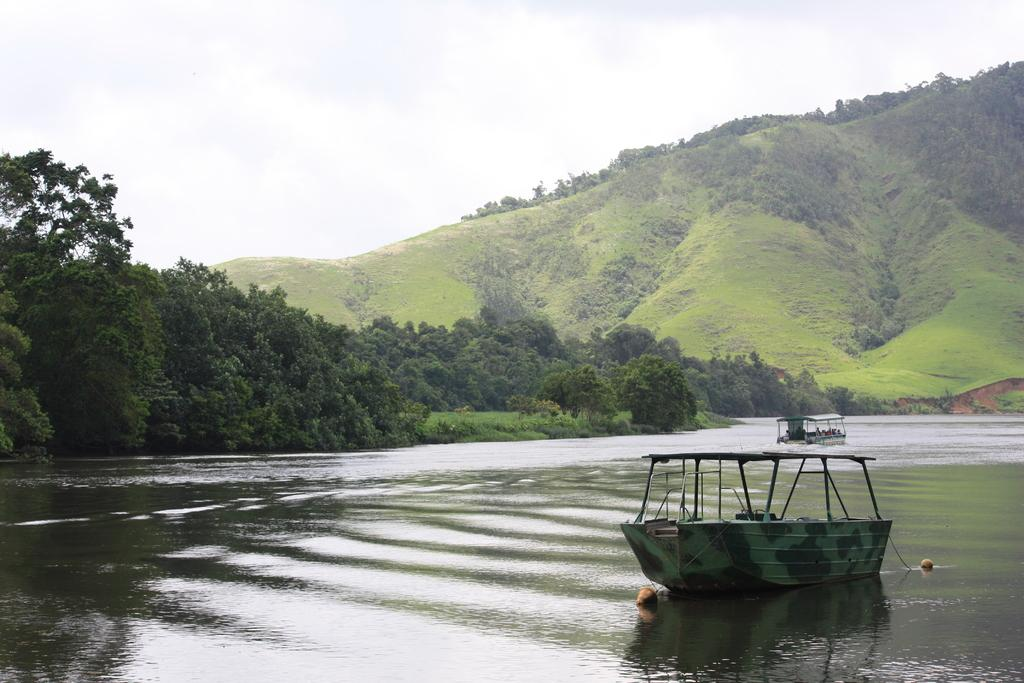What body of water is at the bottom of the image? There is a river at the bottom of the image. What is in the river? There are boats in the river. What can be seen in the distance in the image? There are mountains and trees in the background of the image. What type of vegetation is visible in the background of the image? Plants are visible in the background of the image. What is visible at the top of the image? The sky is visible at the top of the image. What hobbies do the mountains in the image enjoy? Mountains do not have hobbies, as they are inanimate objects. How many thumbs can be seen on the plants in the image? There are no thumbs visible in the image, as plants do not have thumbs. 